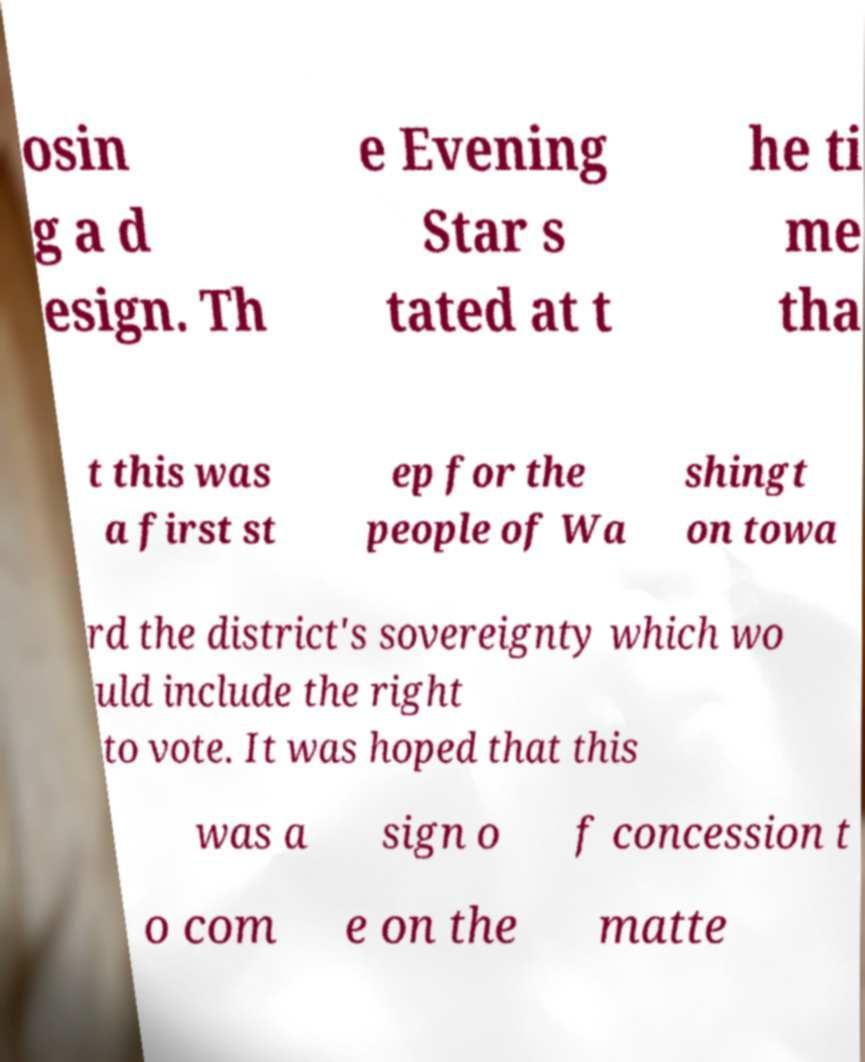Could you assist in decoding the text presented in this image and type it out clearly? osin g a d esign. Th e Evening Star s tated at t he ti me tha t this was a first st ep for the people of Wa shingt on towa rd the district's sovereignty which wo uld include the right to vote. It was hoped that this was a sign o f concession t o com e on the matte 